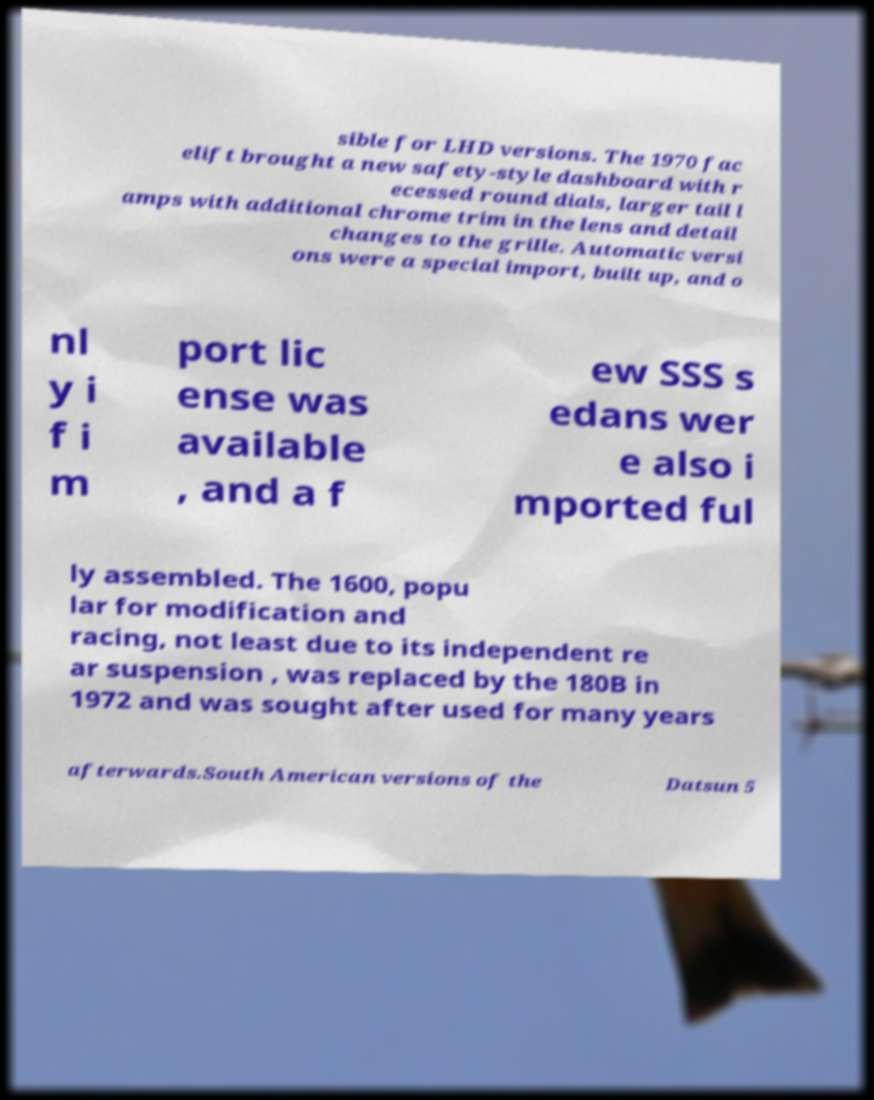I need the written content from this picture converted into text. Can you do that? sible for LHD versions. The 1970 fac elift brought a new safety-style dashboard with r ecessed round dials, larger tail l amps with additional chrome trim in the lens and detail changes to the grille. Automatic versi ons were a special import, built up, and o nl y i f i m port lic ense was available , and a f ew SSS s edans wer e also i mported ful ly assembled. The 1600, popu lar for modification and racing, not least due to its independent re ar suspension , was replaced by the 180B in 1972 and was sought after used for many years afterwards.South American versions of the Datsun 5 